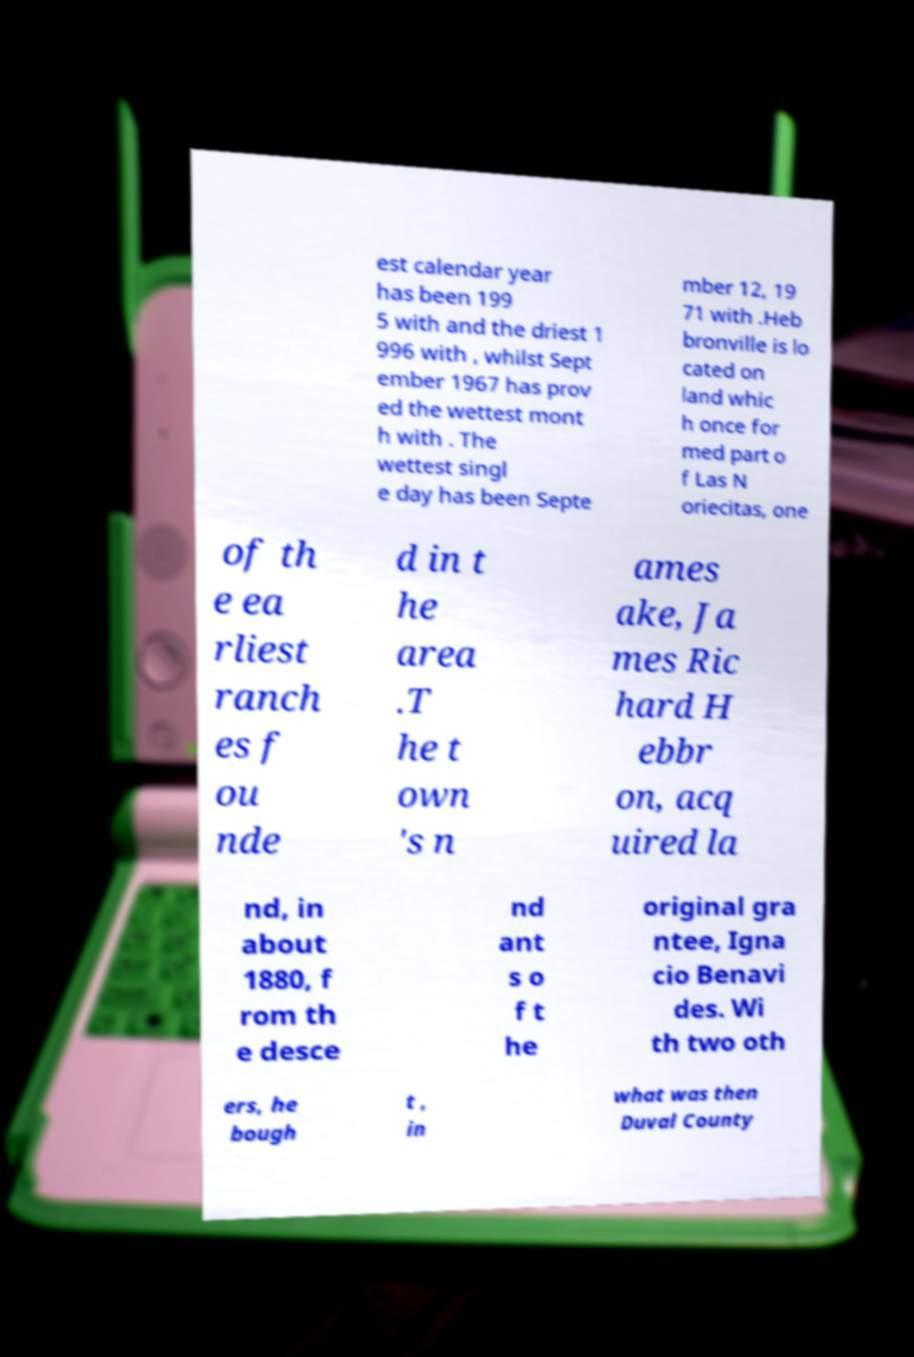There's text embedded in this image that I need extracted. Can you transcribe it verbatim? est calendar year has been 199 5 with and the driest 1 996 with , whilst Sept ember 1967 has prov ed the wettest mont h with . The wettest singl e day has been Septe mber 12, 19 71 with .Heb bronville is lo cated on land whic h once for med part o f Las N oriecitas, one of th e ea rliest ranch es f ou nde d in t he area .T he t own 's n ames ake, Ja mes Ric hard H ebbr on, acq uired la nd, in about 1880, f rom th e desce nd ant s o f t he original gra ntee, Igna cio Benavi des. Wi th two oth ers, he bough t , in what was then Duval County 